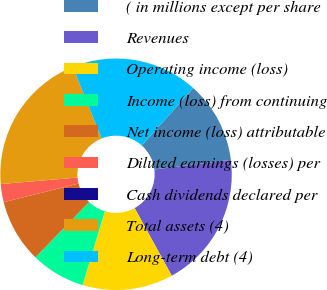<chart> <loc_0><loc_0><loc_500><loc_500><pie_chart><fcel>( in millions except per share<fcel>Revenues<fcel>Operating income (loss)<fcel>Income (loss) from continuing<fcel>Net income (loss) attributable<fcel>Diluted earnings (losses) per<fcel>Cash dividends declared per<fcel>Total assets (4)<fcel>Long-term debt (4)<nl><fcel>11.39%<fcel>18.99%<fcel>12.66%<fcel>7.6%<fcel>8.86%<fcel>2.53%<fcel>0.0%<fcel>20.25%<fcel>17.72%<nl></chart> 